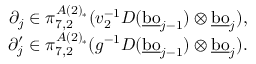<formula> <loc_0><loc_0><loc_500><loc_500>\begin{array} { r } { \partial _ { j } \in \pi _ { 7 , 2 } ^ { A ( 2 ) _ { * } } ( v _ { 2 } ^ { - 1 } D ( \underline { b o } _ { j - 1 } ) \otimes \underline { b o } _ { j } ) , } \\ { \partial _ { j } ^ { \prime } \in \pi _ { 7 , 2 } ^ { A ( 2 ) _ { * } } ( g ^ { - 1 } D ( \underline { b o } _ { j - 1 } ) \otimes \underline { b o } _ { j } ) . } \end{array}</formula> 